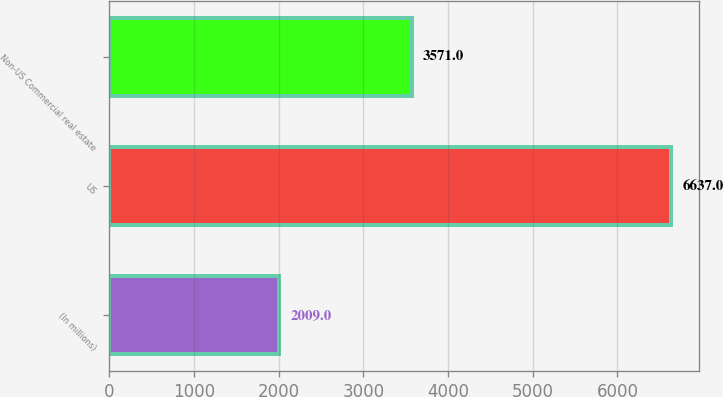Convert chart. <chart><loc_0><loc_0><loc_500><loc_500><bar_chart><fcel>(In millions)<fcel>US<fcel>Non-US Commercial real estate<nl><fcel>2009<fcel>6637<fcel>3571<nl></chart> 